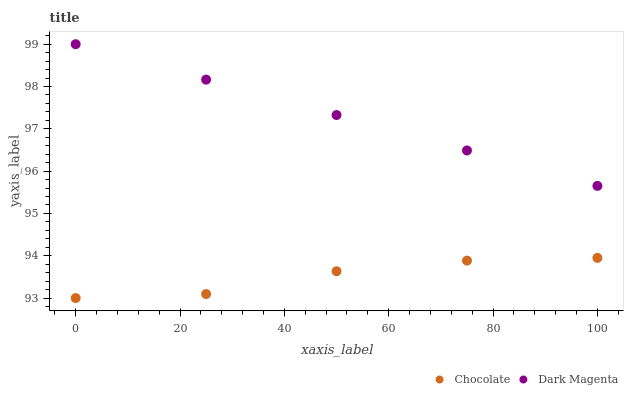Does Chocolate have the minimum area under the curve?
Answer yes or no. Yes. Does Dark Magenta have the maximum area under the curve?
Answer yes or no. Yes. Does Chocolate have the maximum area under the curve?
Answer yes or no. No. Is Dark Magenta the smoothest?
Answer yes or no. Yes. Is Chocolate the roughest?
Answer yes or no. Yes. Is Chocolate the smoothest?
Answer yes or no. No. Does Chocolate have the lowest value?
Answer yes or no. Yes. Does Dark Magenta have the highest value?
Answer yes or no. Yes. Does Chocolate have the highest value?
Answer yes or no. No. Is Chocolate less than Dark Magenta?
Answer yes or no. Yes. Is Dark Magenta greater than Chocolate?
Answer yes or no. Yes. Does Chocolate intersect Dark Magenta?
Answer yes or no. No. 